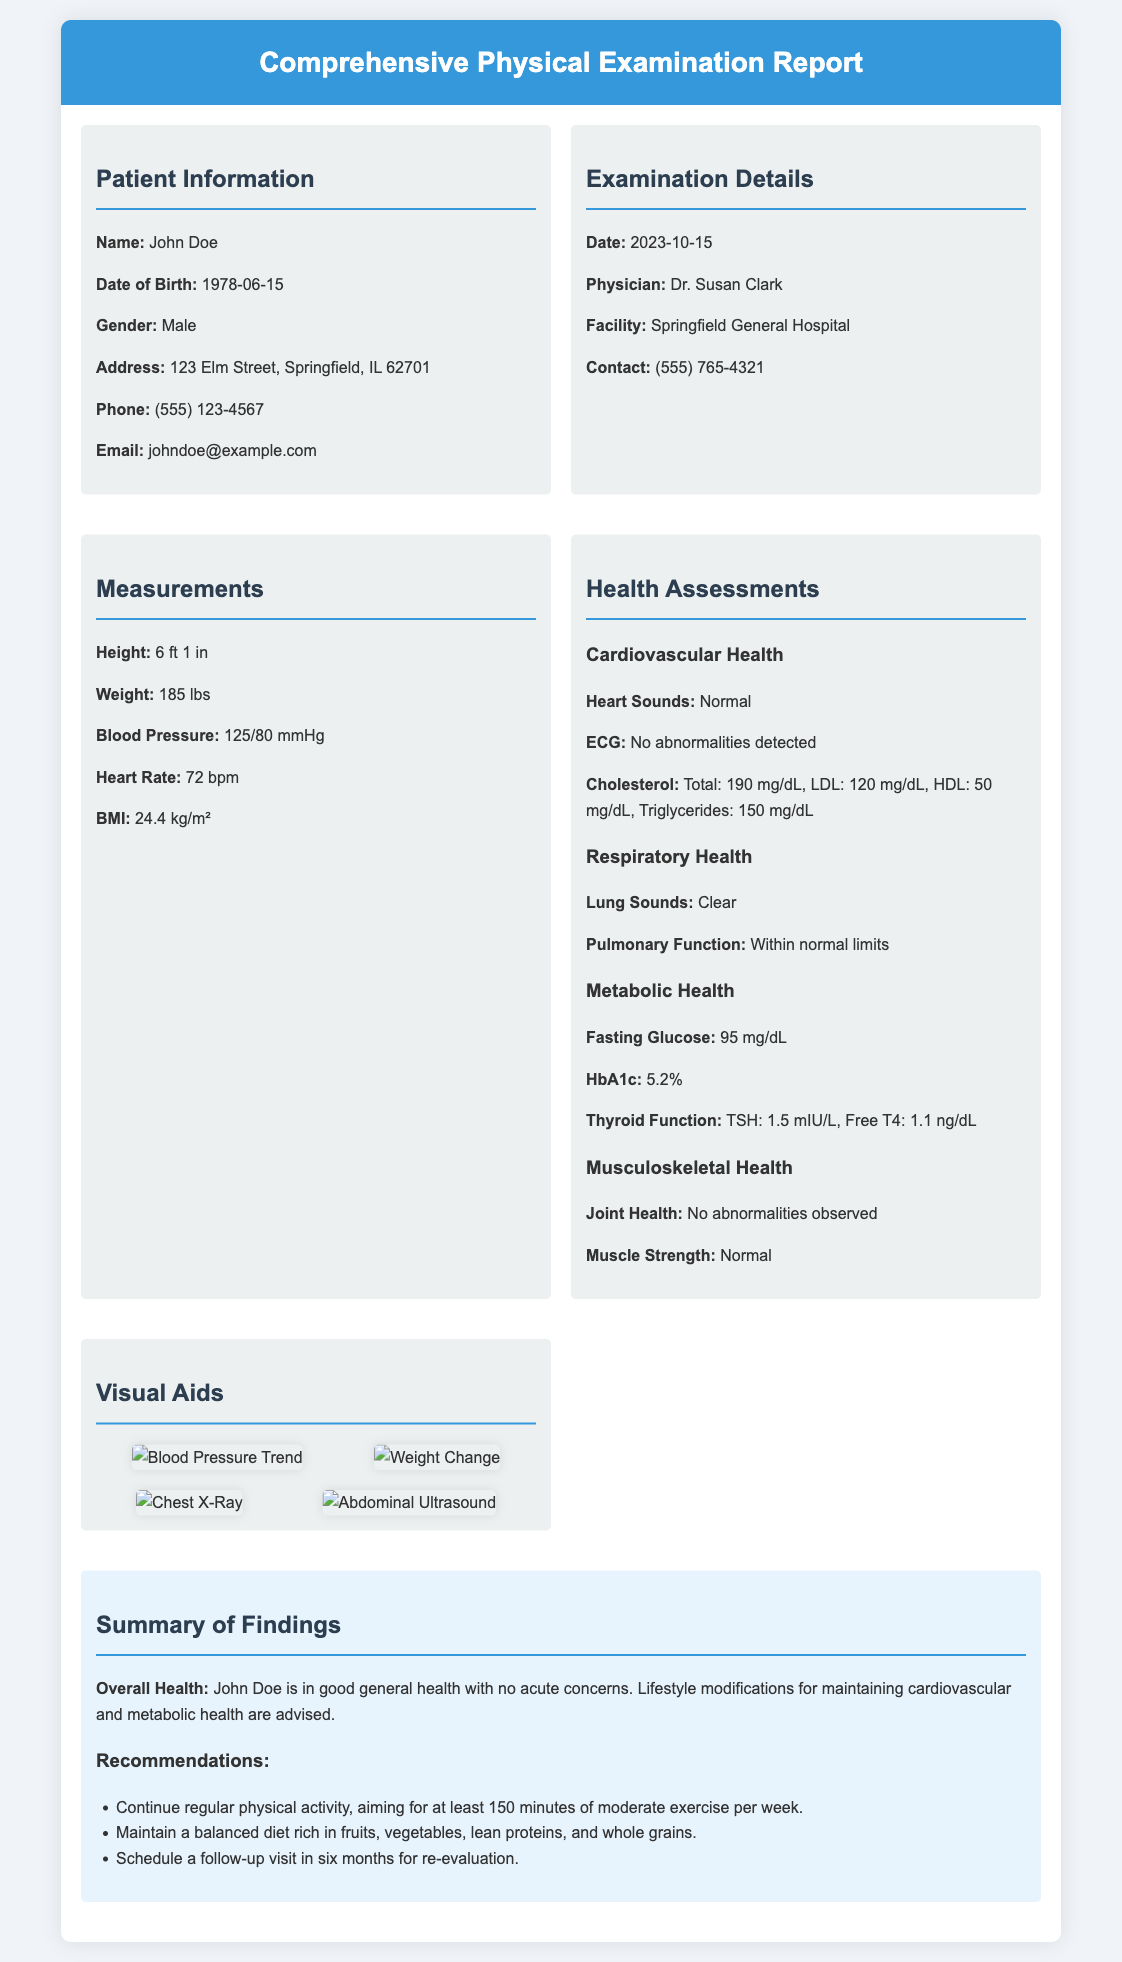What is the patient's name? The document states the patient's name as John Doe.
Answer: John Doe What is the date of the examination? The examination date is specifically mentioned in the document as October 15, 2023.
Answer: 2023-10-15 What is the patient's height? The document lists the height of the patient as 6 feet 1 inch.
Answer: 6 ft 1 in What is the recorded blood pressure? The blood pressure is documented as 125 over 80 mmHg, providing both systolic and diastolic numbers.
Answer: 125/80 mmHg What was the cholesterol level from the health assessments? The cholesterol level provided in the assessment section shows total cholesterol at 190 mg/dL.
Answer: 190 mg/dL What does the summary state about the patient's general health? The summary concludes that the patient is in good general health with no acute concerns.
Answer: Good general health Are there any recommendations for physical activity? The recommendations specify continuing regular physical activity, emphasizing a minimum of 150 minutes per week.
Answer: 150 minutes What is the physician's name? The document names the physician responsible for the examination as Dr. Susan Clark.
Answer: Dr. Susan Clark What is the patient's email address? The email address for the patient is given as johndoe@example.com in the document.
Answer: johndoe@example.com What is the TSH level from the metabolic health assessment? The document reports the TSH level as 1.5 mIU/L under metabolic health assessment.
Answer: 1.5 mIU/L 